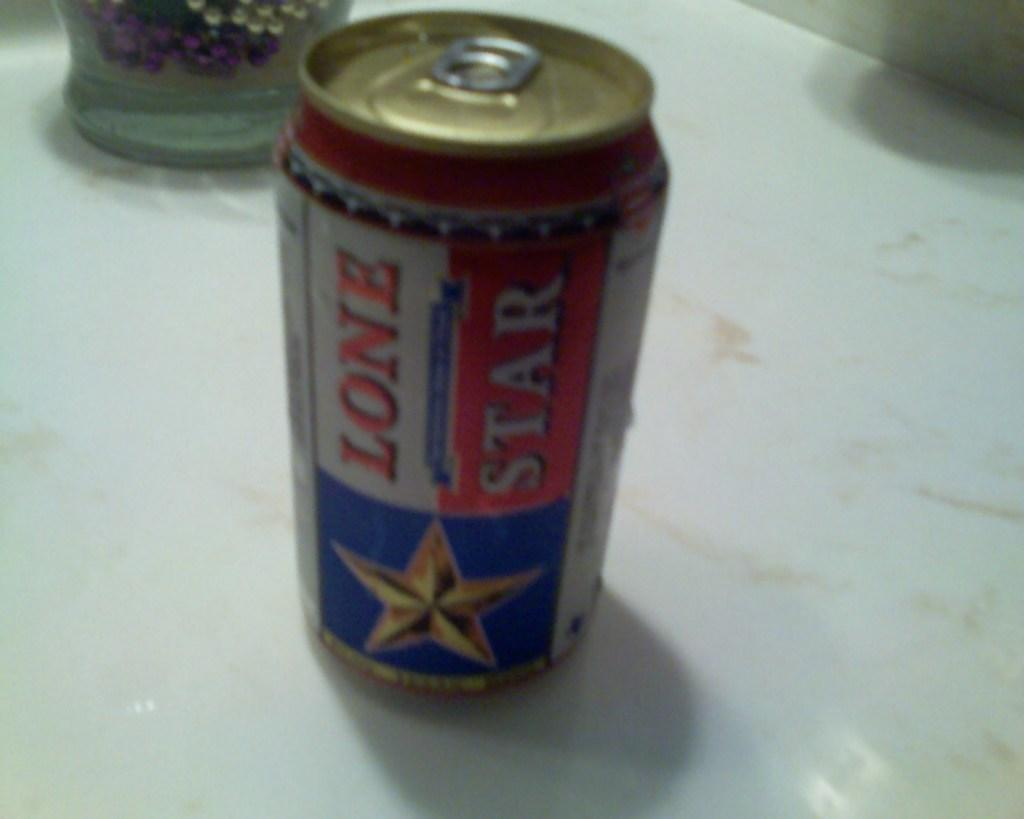Provide a one-sentence caption for the provided image. A lone star beer rests on a counter. 